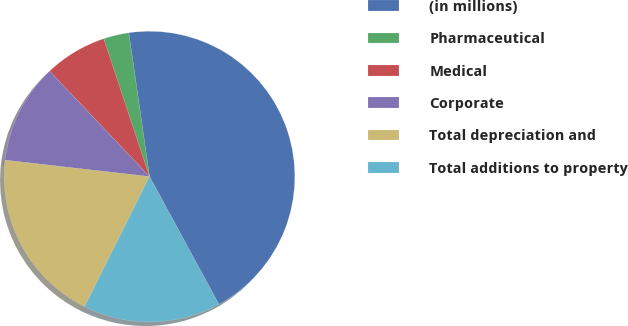Convert chart. <chart><loc_0><loc_0><loc_500><loc_500><pie_chart><fcel>(in millions)<fcel>Pharmaceutical<fcel>Medical<fcel>Corporate<fcel>Total depreciation and<fcel>Total additions to property<nl><fcel>44.36%<fcel>2.82%<fcel>6.97%<fcel>11.13%<fcel>19.44%<fcel>15.28%<nl></chart> 